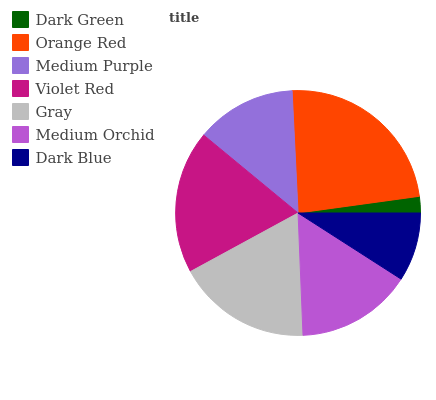Is Dark Green the minimum?
Answer yes or no. Yes. Is Orange Red the maximum?
Answer yes or no. Yes. Is Medium Purple the minimum?
Answer yes or no. No. Is Medium Purple the maximum?
Answer yes or no. No. Is Orange Red greater than Medium Purple?
Answer yes or no. Yes. Is Medium Purple less than Orange Red?
Answer yes or no. Yes. Is Medium Purple greater than Orange Red?
Answer yes or no. No. Is Orange Red less than Medium Purple?
Answer yes or no. No. Is Medium Orchid the high median?
Answer yes or no. Yes. Is Medium Orchid the low median?
Answer yes or no. Yes. Is Orange Red the high median?
Answer yes or no. No. Is Dark Green the low median?
Answer yes or no. No. 